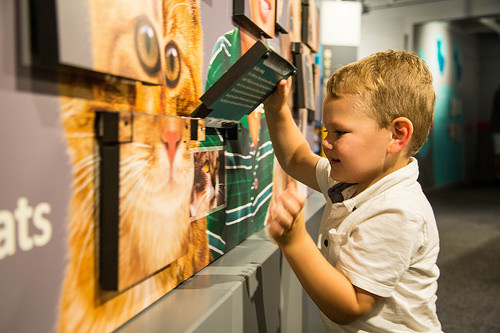<image>
Is the boy behind the wall? No. The boy is not behind the wall. From this viewpoint, the boy appears to be positioned elsewhere in the scene. Is the cat in front of the child? Yes. The cat is positioned in front of the child, appearing closer to the camera viewpoint. 